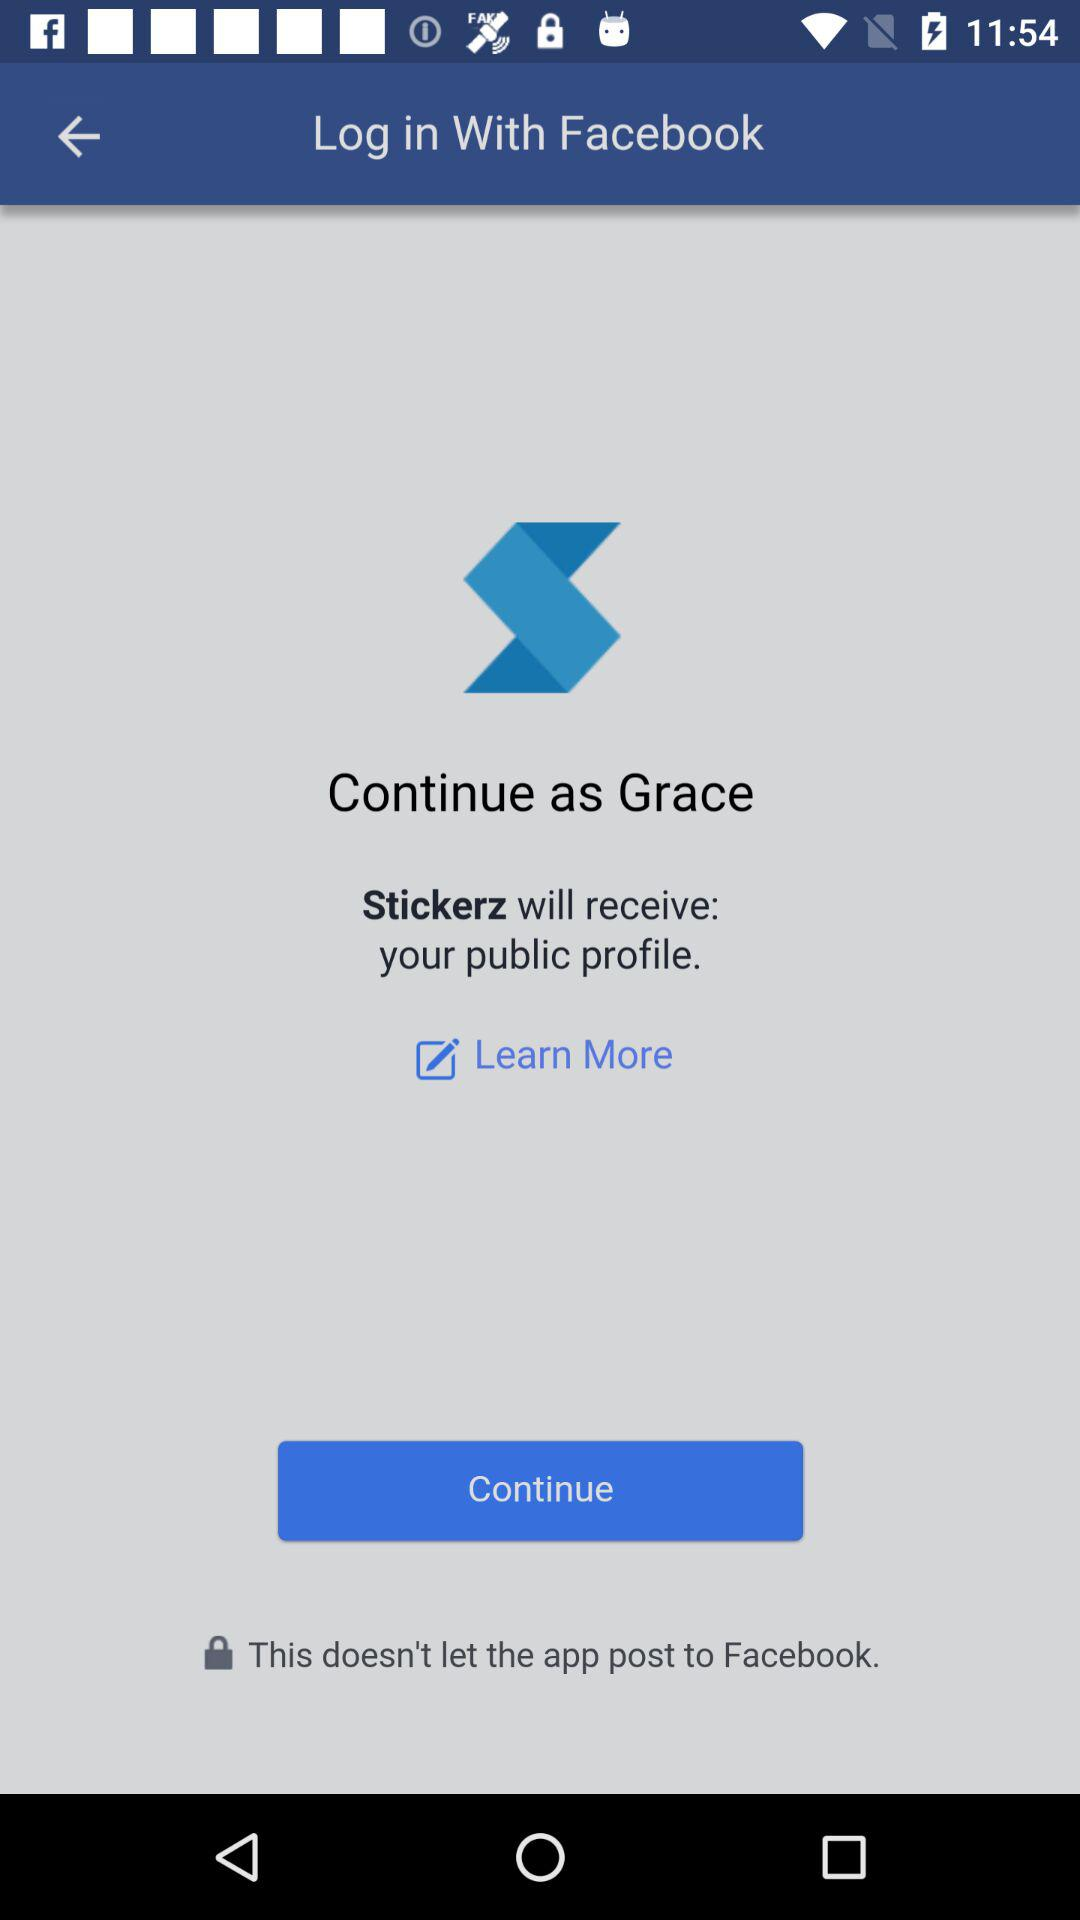What is the name of the user? The name of the user is Grace. 